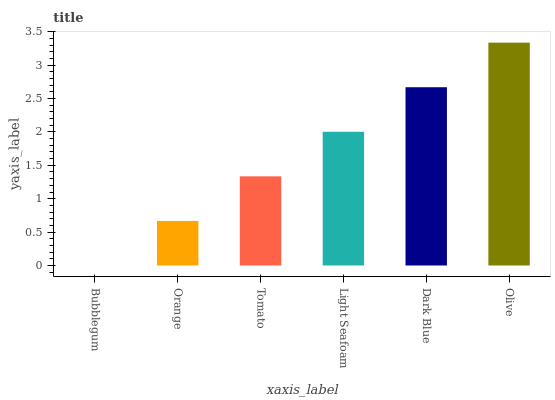Is Bubblegum the minimum?
Answer yes or no. Yes. Is Olive the maximum?
Answer yes or no. Yes. Is Orange the minimum?
Answer yes or no. No. Is Orange the maximum?
Answer yes or no. No. Is Orange greater than Bubblegum?
Answer yes or no. Yes. Is Bubblegum less than Orange?
Answer yes or no. Yes. Is Bubblegum greater than Orange?
Answer yes or no. No. Is Orange less than Bubblegum?
Answer yes or no. No. Is Light Seafoam the high median?
Answer yes or no. Yes. Is Tomato the low median?
Answer yes or no. Yes. Is Orange the high median?
Answer yes or no. No. Is Light Seafoam the low median?
Answer yes or no. No. 